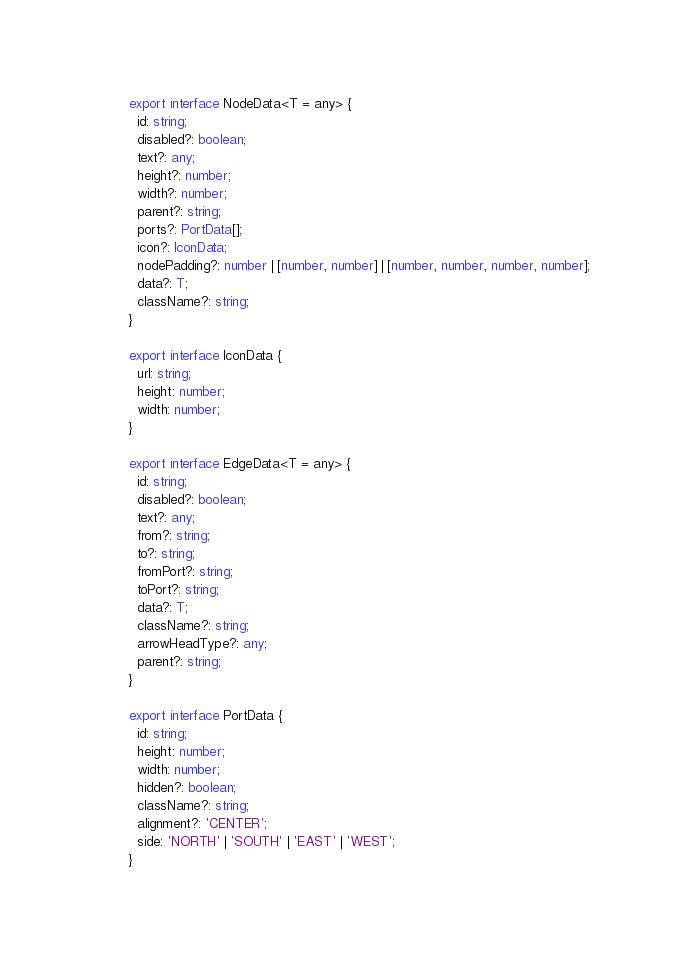Convert code to text. <code><loc_0><loc_0><loc_500><loc_500><_TypeScript_>export interface NodeData<T = any> {
  id: string;
  disabled?: boolean;
  text?: any;
  height?: number;
  width?: number;
  parent?: string;
  ports?: PortData[];
  icon?: IconData;
  nodePadding?: number | [number, number] | [number, number, number, number];
  data?: T;
  className?: string;
}

export interface IconData {
  url: string;
  height: number;
  width: number;
}

export interface EdgeData<T = any> {
  id: string;
  disabled?: boolean;
  text?: any;
  from?: string;
  to?: string;
  fromPort?: string;
  toPort?: string;
  data?: T;
  className?: string;
  arrowHeadType?: any;
  parent?: string;
}

export interface PortData {
  id: string;
  height: number;
  width: number;
  hidden?: boolean;
  className?: string;
  alignment?: 'CENTER';
  side: 'NORTH' | 'SOUTH' | 'EAST' | 'WEST';
}
</code> 